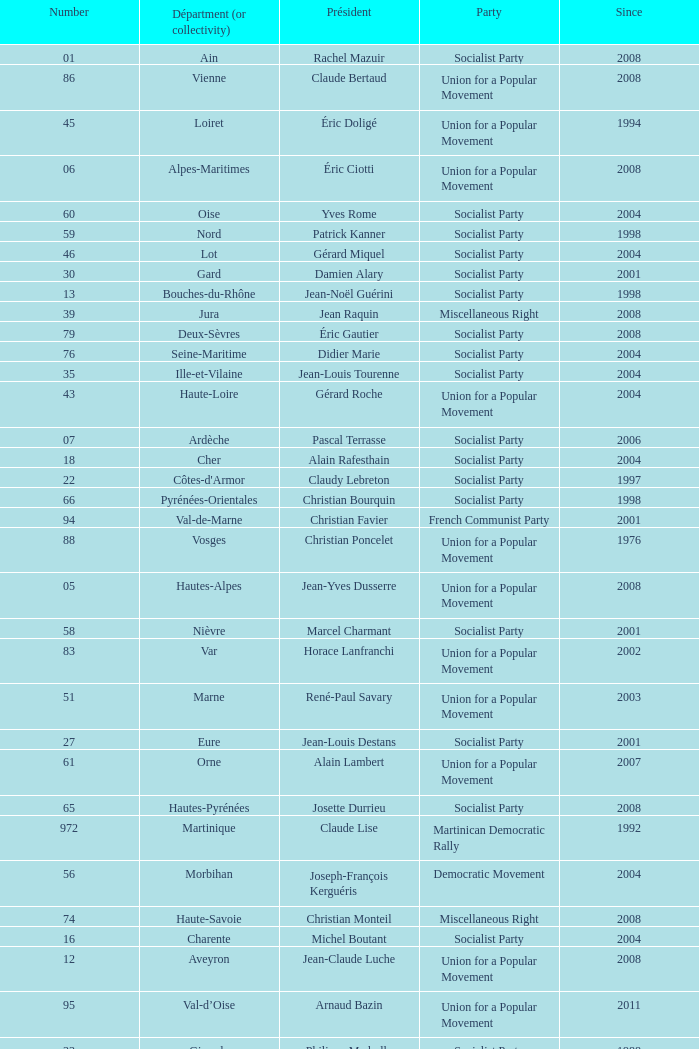Which department has Guy-Dominique Kennel as president since 2008? Bas-Rhin. 